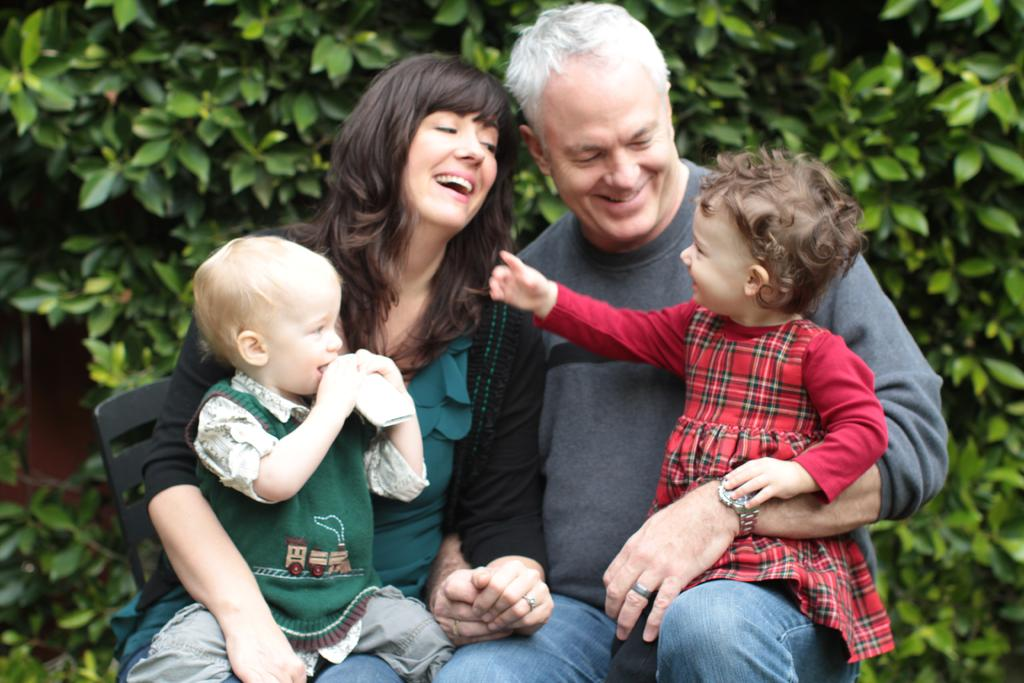Who are the people in the center of the image? There is a man and a woman in the center of the image. What are the man and woman doing in the image? The man and woman are sitting in the image. What are the man and woman holding? The man and woman are holding babies in the image. What can be seen in the background of the image? There are plants in the background of the image. What type of screw can be seen in the image? There is no screw present in the image. How many points does the star in the image have? There is no star present in the image. 